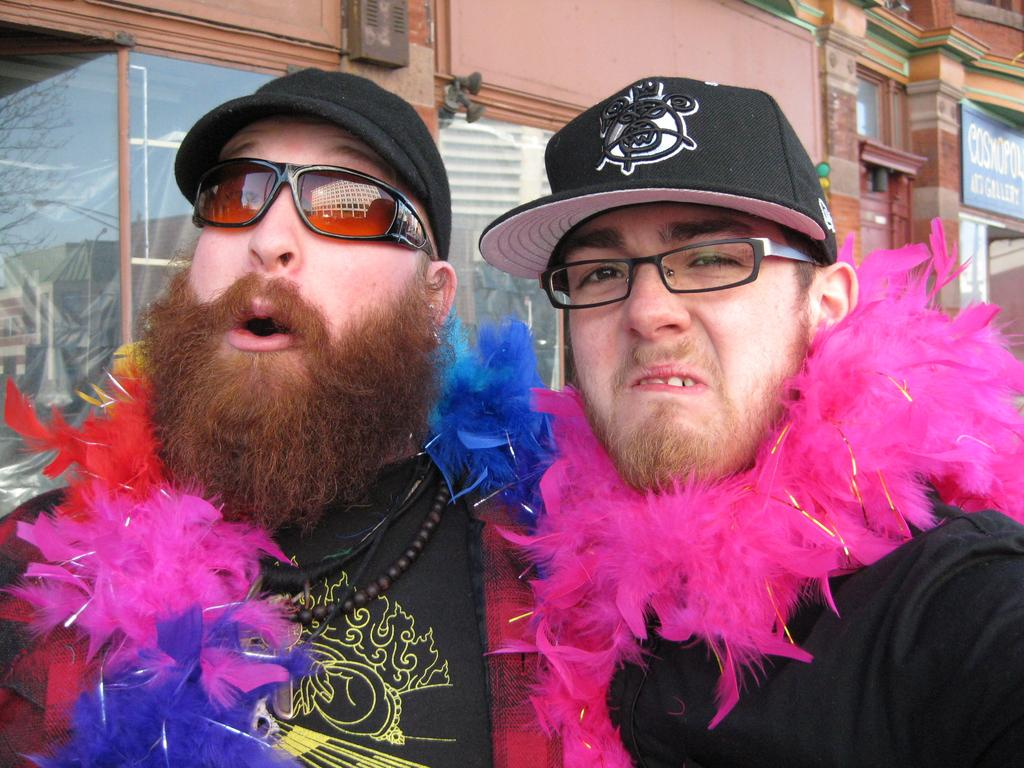How many people are in the image? There are two people in the image. What are the people wearing on their heads? The people are wearing black helmets. What else are the people wearing? The people are wearing black t-shirts. What can be seen in the background of the image? There are buildings in the background of the image. Can you see any cords attached to the people in the image? There are no cords visible in the image. What grade are the people in the image teaching or learning? The image does not provide any information about the people's grade or educational activities. 